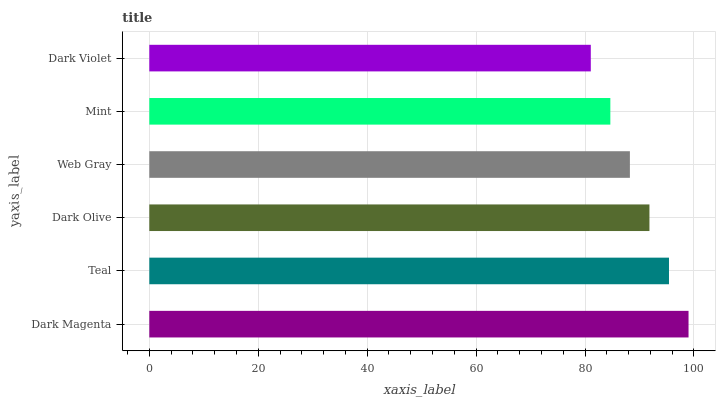Is Dark Violet the minimum?
Answer yes or no. Yes. Is Dark Magenta the maximum?
Answer yes or no. Yes. Is Teal the minimum?
Answer yes or no. No. Is Teal the maximum?
Answer yes or no. No. Is Dark Magenta greater than Teal?
Answer yes or no. Yes. Is Teal less than Dark Magenta?
Answer yes or no. Yes. Is Teal greater than Dark Magenta?
Answer yes or no. No. Is Dark Magenta less than Teal?
Answer yes or no. No. Is Dark Olive the high median?
Answer yes or no. Yes. Is Web Gray the low median?
Answer yes or no. Yes. Is Teal the high median?
Answer yes or no. No. Is Dark Olive the low median?
Answer yes or no. No. 